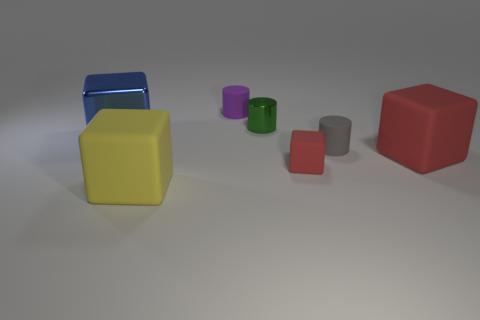Subtract all matte cubes. How many cubes are left? 1 Add 3 big blue metal blocks. How many objects exist? 10 Subtract all green cylinders. How many cylinders are left? 2 Subtract 2 cylinders. How many cylinders are left? 1 Subtract all cubes. How many objects are left? 3 Subtract all blue spheres. How many green cylinders are left? 1 Subtract all purple blocks. Subtract all cyan spheres. How many blocks are left? 4 Subtract all large objects. Subtract all small gray matte cylinders. How many objects are left? 3 Add 5 big yellow matte objects. How many big yellow matte objects are left? 6 Add 2 rubber cylinders. How many rubber cylinders exist? 4 